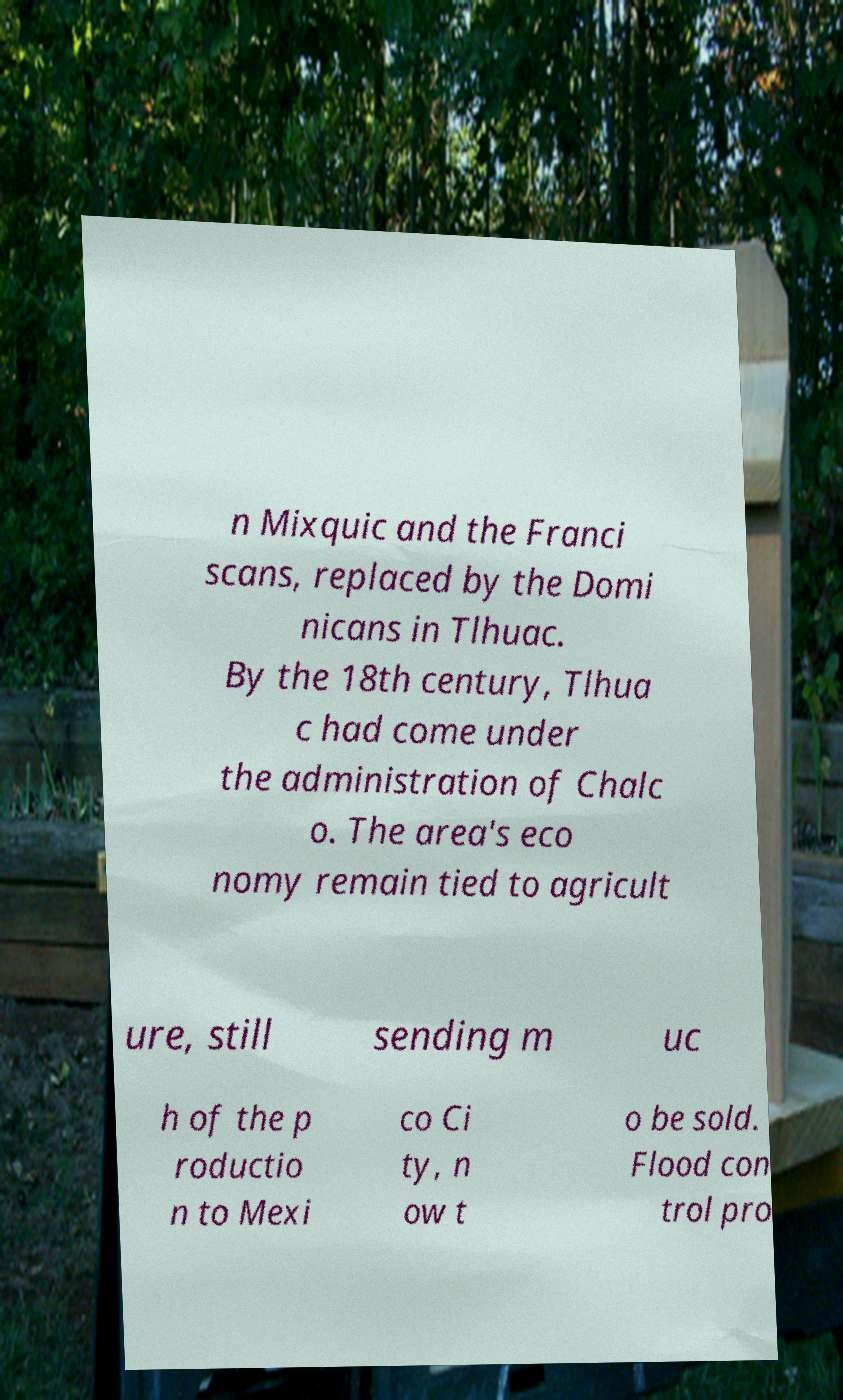Can you read and provide the text displayed in the image?This photo seems to have some interesting text. Can you extract and type it out for me? n Mixquic and the Franci scans, replaced by the Domi nicans in Tlhuac. By the 18th century, Tlhua c had come under the administration of Chalc o. The area's eco nomy remain tied to agricult ure, still sending m uc h of the p roductio n to Mexi co Ci ty, n ow t o be sold. Flood con trol pro 